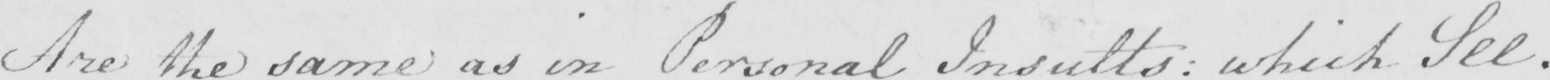What is written in this line of handwriting? Are the same as in Personal Insults  :  which See . 